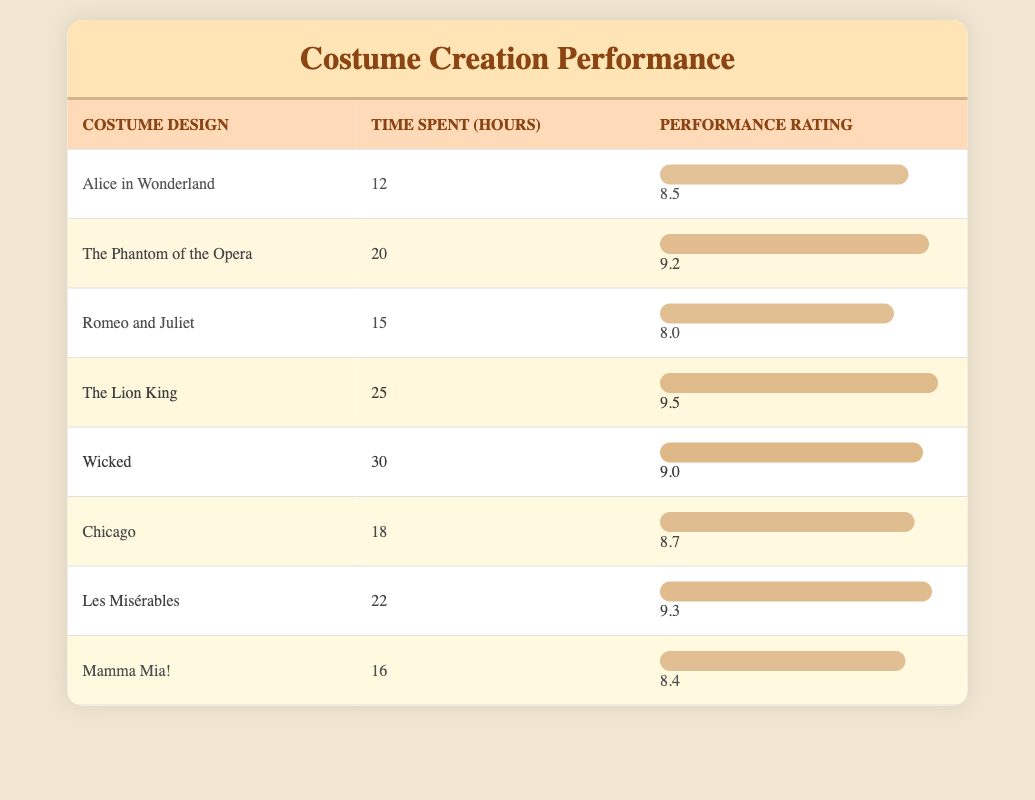What is the performance feedback rating for "The Lion King"? By looking at the table, I can find the row for "The Lion King" and see its corresponding performance feedback rating is listed as 9.5.
Answer: 9.5 What is the time spent creating costumes for "Wicked"? In the table, the row for "Wicked" shows that the time spent creating its costumes is 30 hours.
Answer: 30 hours Is the performance feedback rating for "Mamma Mia!" greater than 8.5? The performance feedback rating for "Mamma Mia!" is 8.4, which is less than 8.5, so the answer is no.
Answer: No What is the average time spent on costume creation for all listed productions? First, I add the total hours: 12 + 20 + 15 + 25 + 30 + 18 + 22 + 16 = 148 hours. Then I divide by the number of productions (8), which gives an average of 148/8 = 18.5 hours.
Answer: 18.5 hours Which costume design received the highest performance feedback rating? Looking through the performance ratings, "The Lion King" has the highest rating at 9.5 compared to others.
Answer: The Lion King What is the difference in performance feedback rating between "Les Misérables" and "Romeo and Juliet"? The performance feedback rating for "Les Misérables" is 9.3, while for "Romeo and Juliet" it is 8.0. The difference is 9.3 - 8.0 = 1.3.
Answer: 1.3 How many productions took more than 20 hours to create costumes? Checking the table, the productions that took more than 20 hours are "The Phantom of the Opera" (20), "The Lion King" (25), "Wicked" (30), and "Les Misérables" (22), totaling 4 productions.
Answer: 4 productions Which costume design took the least amount of time to create? By scanning through the time spent, "Alice in Wonderland" required the least time, at 12 hours.
Answer: Alice in Wonderland 